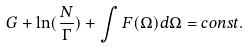Convert formula to latex. <formula><loc_0><loc_0><loc_500><loc_500>G + \ln ( \frac { N } { \Gamma } ) + \int { F ( \Omega ) d \Omega } = c o n s t .</formula> 